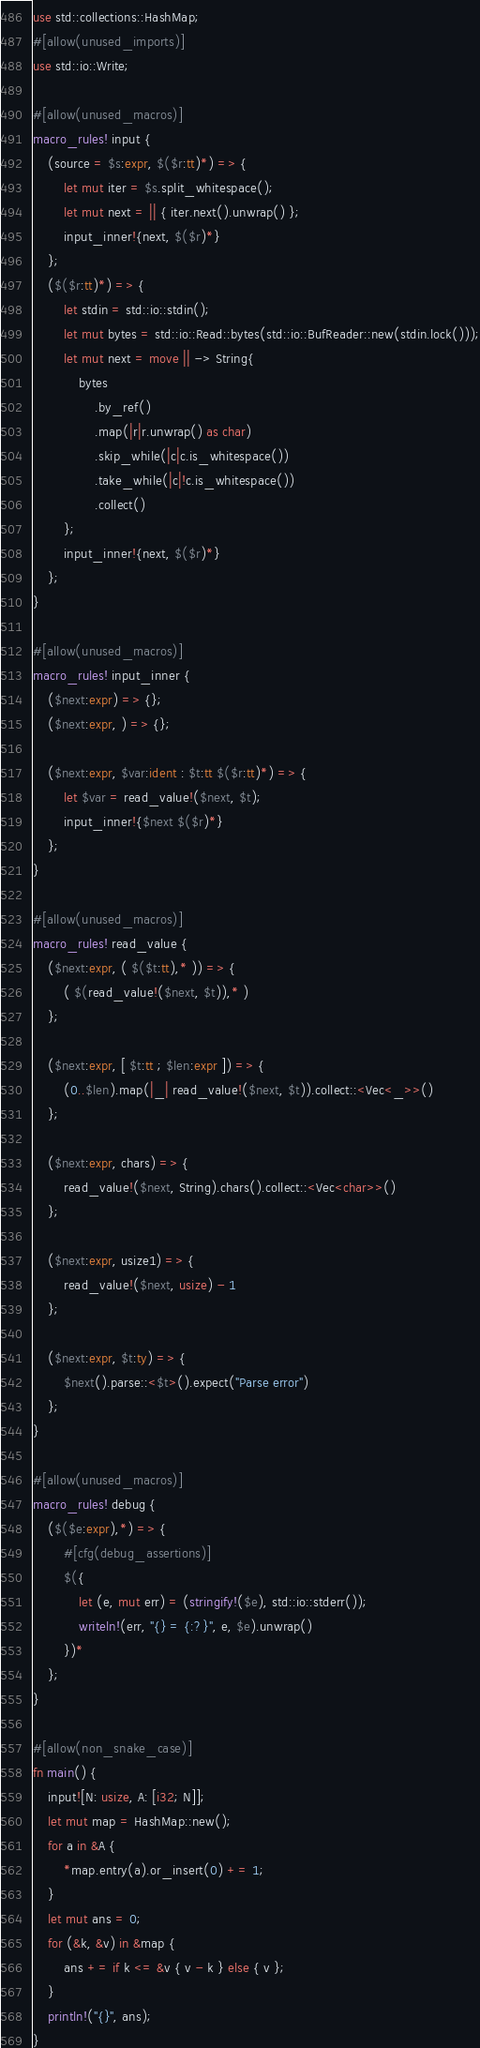<code> <loc_0><loc_0><loc_500><loc_500><_Rust_>use std::collections::HashMap;
#[allow(unused_imports)]
use std::io::Write;

#[allow(unused_macros)]
macro_rules! input {
    (source = $s:expr, $($r:tt)*) => {
        let mut iter = $s.split_whitespace();
        let mut next = || { iter.next().unwrap() };
        input_inner!{next, $($r)*}
    };
    ($($r:tt)*) => {
        let stdin = std::io::stdin();
        let mut bytes = std::io::Read::bytes(std::io::BufReader::new(stdin.lock()));
        let mut next = move || -> String{
            bytes
                .by_ref()
                .map(|r|r.unwrap() as char)
                .skip_while(|c|c.is_whitespace())
                .take_while(|c|!c.is_whitespace())
                .collect()
        };
        input_inner!{next, $($r)*}
    };
}

#[allow(unused_macros)]
macro_rules! input_inner {
    ($next:expr) => {};
    ($next:expr, ) => {};

    ($next:expr, $var:ident : $t:tt $($r:tt)*) => {
        let $var = read_value!($next, $t);
        input_inner!{$next $($r)*}
    };
}

#[allow(unused_macros)]
macro_rules! read_value {
    ($next:expr, ( $($t:tt),* )) => {
        ( $(read_value!($next, $t)),* )
    };

    ($next:expr, [ $t:tt ; $len:expr ]) => {
        (0..$len).map(|_| read_value!($next, $t)).collect::<Vec<_>>()
    };

    ($next:expr, chars) => {
        read_value!($next, String).chars().collect::<Vec<char>>()
    };

    ($next:expr, usize1) => {
        read_value!($next, usize) - 1
    };

    ($next:expr, $t:ty) => {
        $next().parse::<$t>().expect("Parse error")
    };
}

#[allow(unused_macros)]
macro_rules! debug {
    ($($e:expr),*) => {
        #[cfg(debug_assertions)]
        $({
            let (e, mut err) = (stringify!($e), std::io::stderr());
            writeln!(err, "{} = {:?}", e, $e).unwrap()
        })*
    };
}

#[allow(non_snake_case)]
fn main() {
    input![N: usize, A: [i32; N]];
    let mut map = HashMap::new();
    for a in &A {
        *map.entry(a).or_insert(0) += 1;
    }
    let mut ans = 0;
    for (&k, &v) in &map {
        ans += if k <= &v { v - k } else { v };
    }
    println!("{}", ans);
}
</code> 